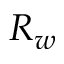<formula> <loc_0><loc_0><loc_500><loc_500>R _ { w }</formula> 